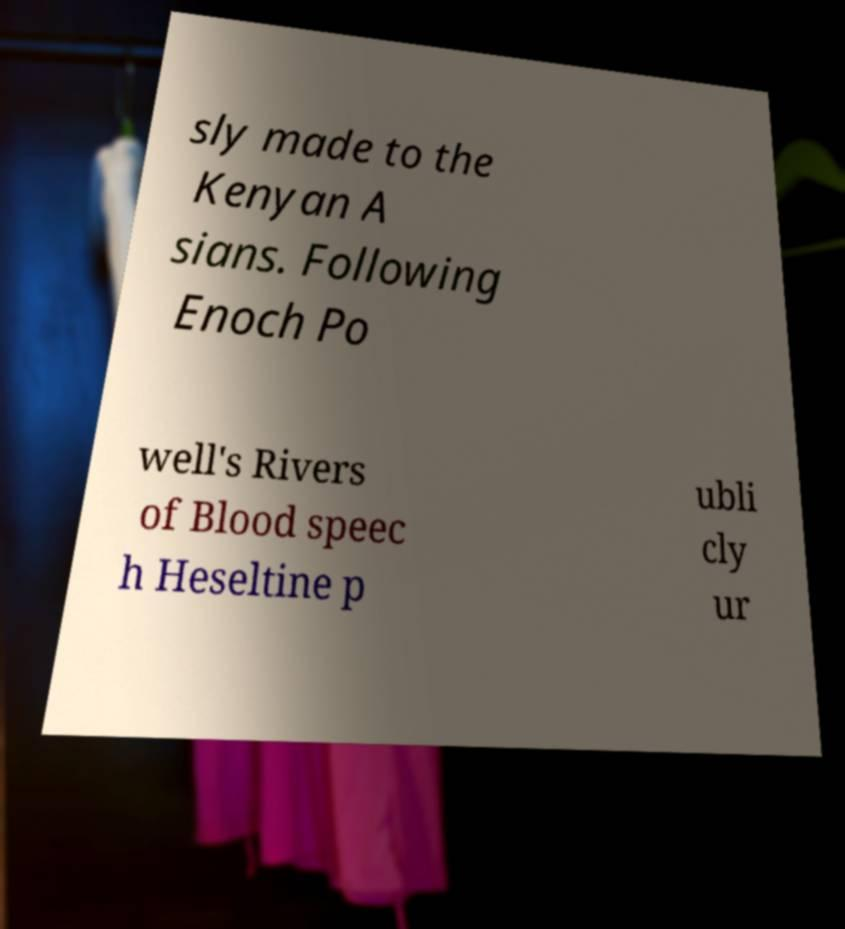There's text embedded in this image that I need extracted. Can you transcribe it verbatim? sly made to the Kenyan A sians. Following Enoch Po well's Rivers of Blood speec h Heseltine p ubli cly ur 